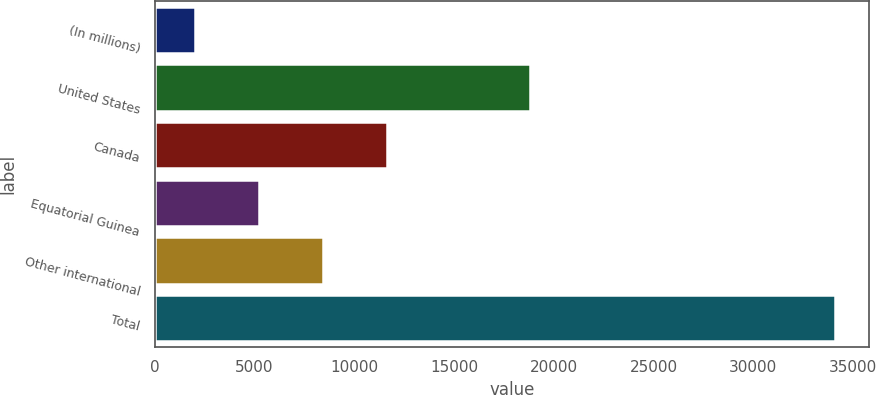<chart> <loc_0><loc_0><loc_500><loc_500><bar_chart><fcel>(In millions)<fcel>United States<fcel>Canada<fcel>Equatorial Guinea<fcel>Other international<fcel>Total<nl><fcel>2009<fcel>18794<fcel>11639.6<fcel>5219.2<fcel>8429.4<fcel>34111<nl></chart> 